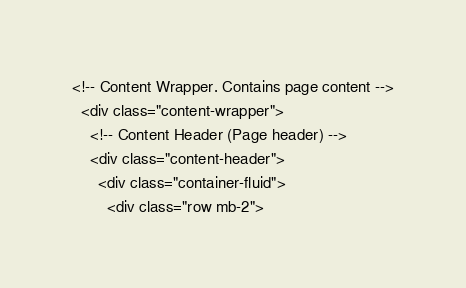<code> <loc_0><loc_0><loc_500><loc_500><_PHP_><!-- Content Wrapper. Contains page content -->
  <div class="content-wrapper">
    <!-- Content Header (Page header) -->
    <div class="content-header">
      <div class="container-fluid">
        <div class="row mb-2"></code> 